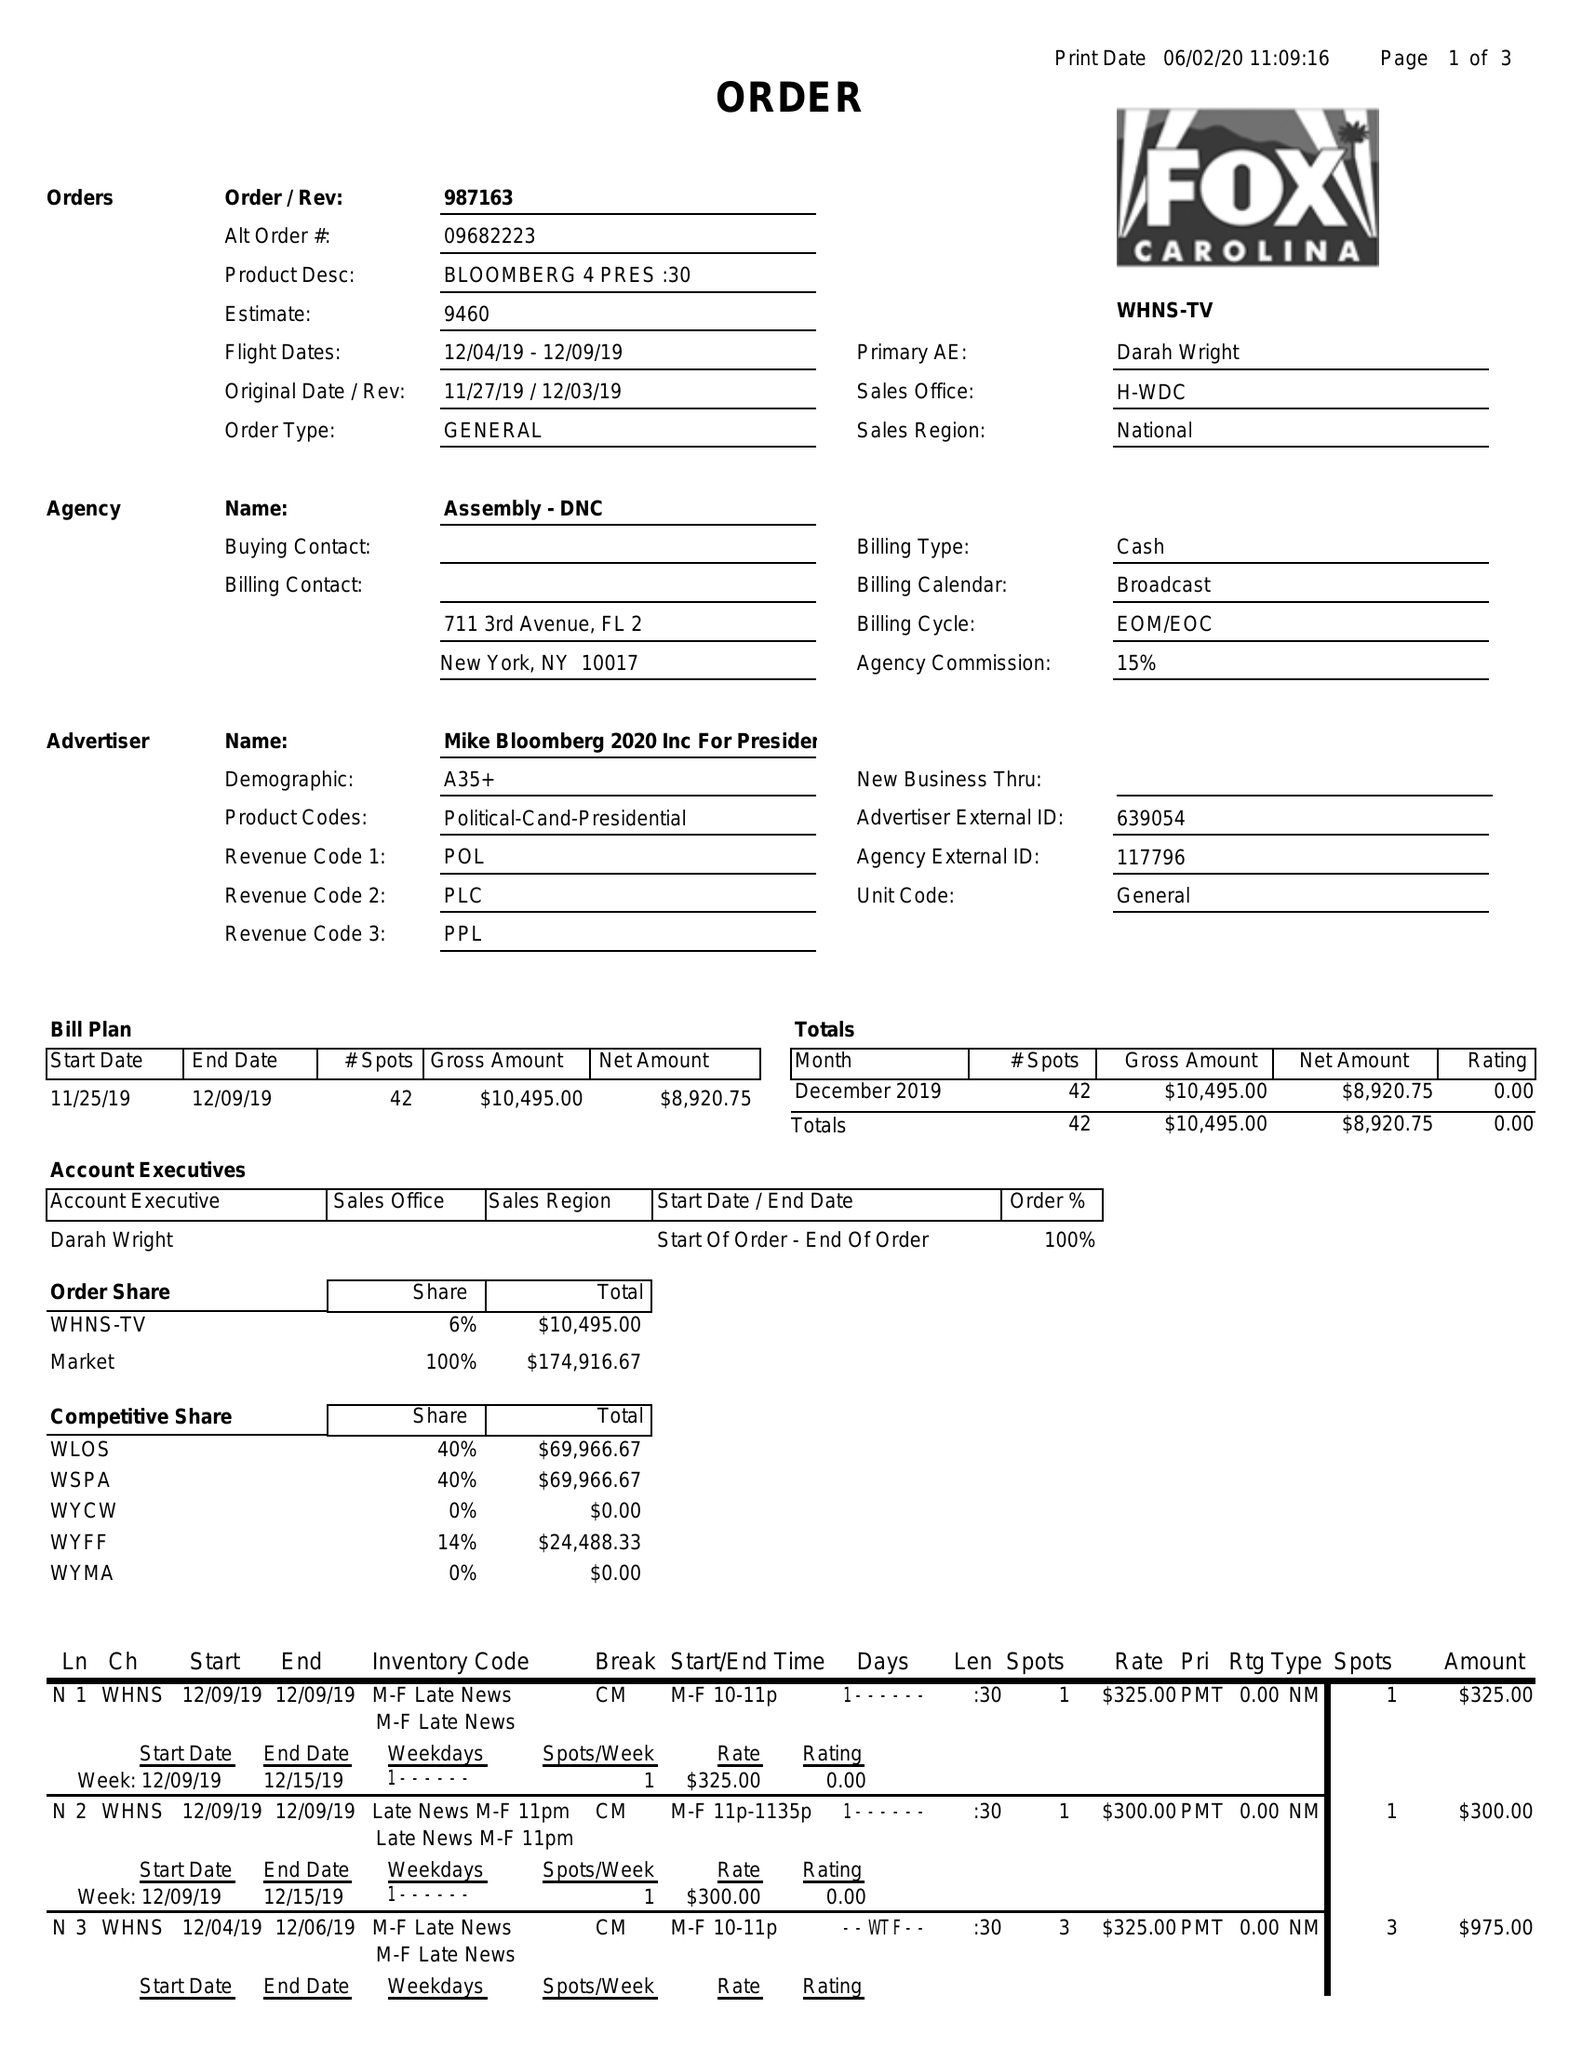What is the value for the gross_amount?
Answer the question using a single word or phrase. 10495.00 